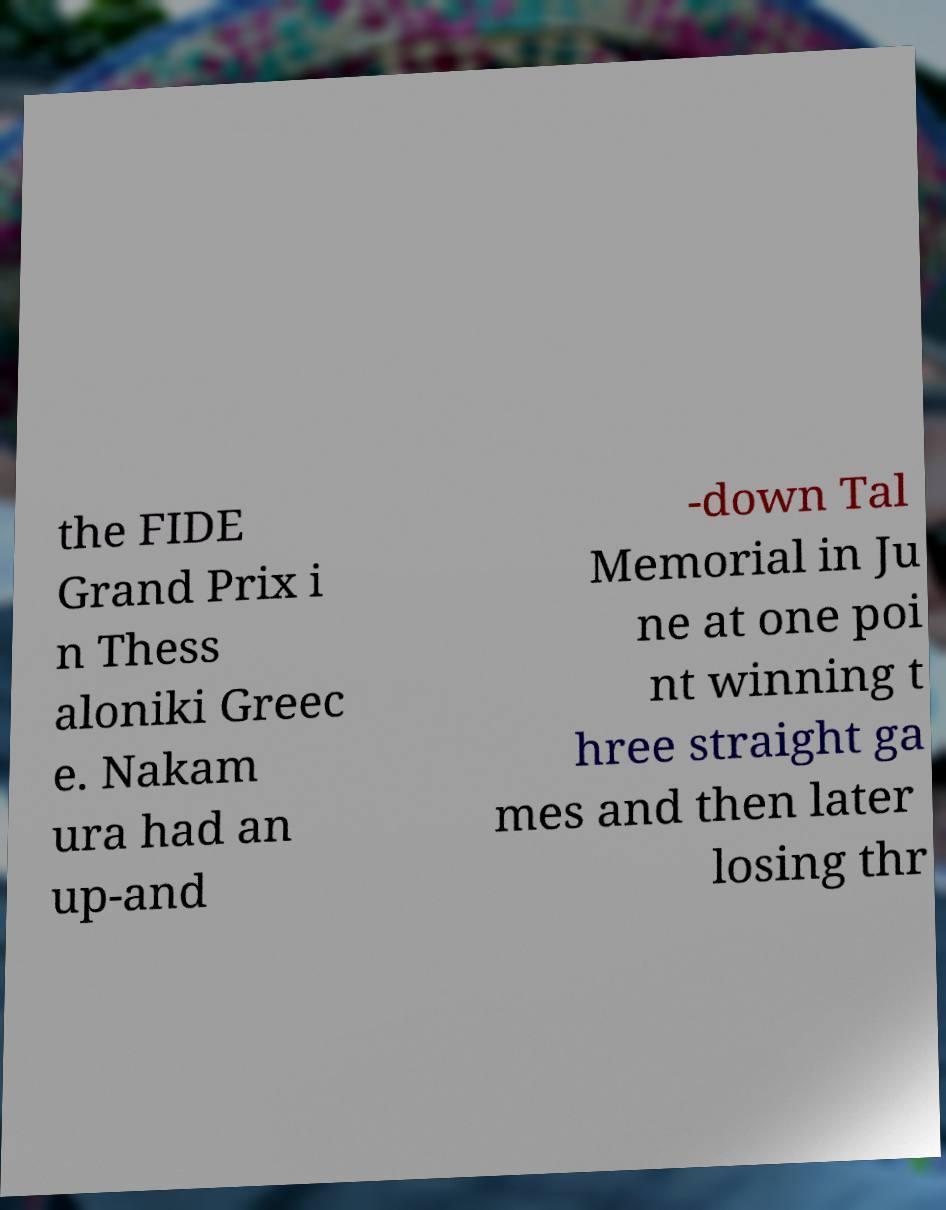Please read and relay the text visible in this image. What does it say? the FIDE Grand Prix i n Thess aloniki Greec e. Nakam ura had an up-and -down Tal Memorial in Ju ne at one poi nt winning t hree straight ga mes and then later losing thr 